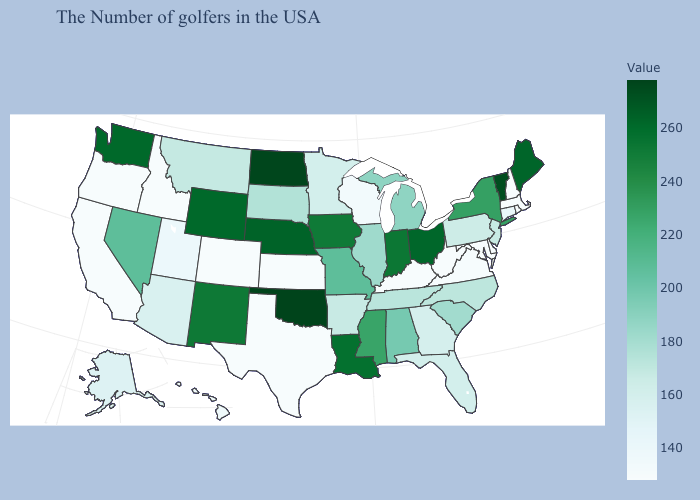Does the map have missing data?
Short answer required. No. Is the legend a continuous bar?
Short answer required. Yes. Does Iowa have a lower value than North Dakota?
Keep it brief. Yes. Among the states that border Georgia , does Florida have the lowest value?
Answer briefly. Yes. Which states hav the highest value in the MidWest?
Short answer required. North Dakota. Among the states that border Delaware , which have the highest value?
Give a very brief answer. New Jersey. 